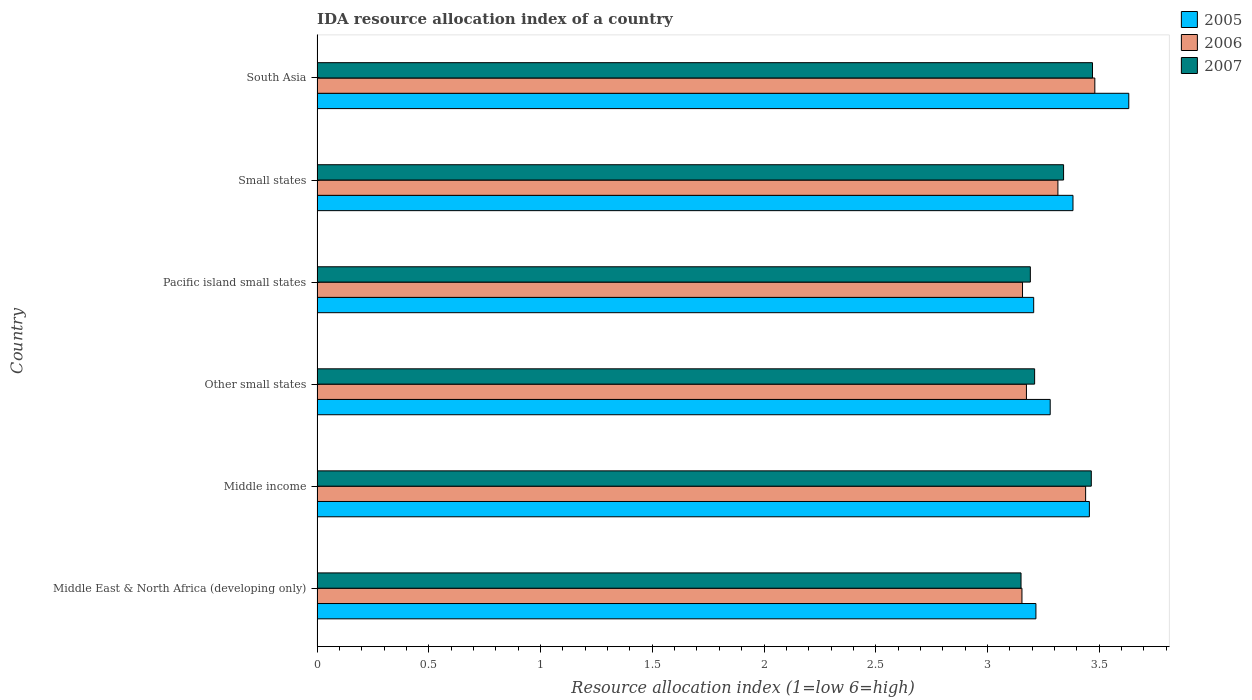How many different coloured bars are there?
Keep it short and to the point. 3. How many groups of bars are there?
Give a very brief answer. 6. Are the number of bars per tick equal to the number of legend labels?
Keep it short and to the point. Yes. Are the number of bars on each tick of the Y-axis equal?
Ensure brevity in your answer.  Yes. What is the label of the 3rd group of bars from the top?
Provide a short and direct response. Pacific island small states. In how many cases, is the number of bars for a given country not equal to the number of legend labels?
Your response must be concise. 0. What is the IDA resource allocation index in 2006 in Small states?
Make the answer very short. 3.31. Across all countries, what is the maximum IDA resource allocation index in 2006?
Your answer should be compact. 3.48. Across all countries, what is the minimum IDA resource allocation index in 2006?
Offer a very short reply. 3.15. In which country was the IDA resource allocation index in 2007 maximum?
Ensure brevity in your answer.  South Asia. In which country was the IDA resource allocation index in 2007 minimum?
Ensure brevity in your answer.  Middle East & North Africa (developing only). What is the total IDA resource allocation index in 2007 in the graph?
Offer a very short reply. 19.83. What is the difference between the IDA resource allocation index in 2005 in Other small states and that in South Asia?
Your response must be concise. -0.35. What is the difference between the IDA resource allocation index in 2006 in Other small states and the IDA resource allocation index in 2007 in Small states?
Your response must be concise. -0.17. What is the average IDA resource allocation index in 2006 per country?
Your answer should be compact. 3.29. What is the difference between the IDA resource allocation index in 2006 and IDA resource allocation index in 2005 in Small states?
Provide a short and direct response. -0.07. In how many countries, is the IDA resource allocation index in 2007 greater than 1 ?
Make the answer very short. 6. What is the ratio of the IDA resource allocation index in 2006 in Middle income to that in Other small states?
Give a very brief answer. 1.08. What is the difference between the highest and the second highest IDA resource allocation index in 2005?
Give a very brief answer. 0.18. What is the difference between the highest and the lowest IDA resource allocation index in 2005?
Keep it short and to the point. 0.43. In how many countries, is the IDA resource allocation index in 2005 greater than the average IDA resource allocation index in 2005 taken over all countries?
Your response must be concise. 3. What does the 1st bar from the top in Other small states represents?
Offer a terse response. 2007. What does the 1st bar from the bottom in Small states represents?
Your answer should be compact. 2005. Is it the case that in every country, the sum of the IDA resource allocation index in 2005 and IDA resource allocation index in 2007 is greater than the IDA resource allocation index in 2006?
Provide a short and direct response. Yes. How many bars are there?
Your answer should be compact. 18. Are the values on the major ticks of X-axis written in scientific E-notation?
Provide a succinct answer. No. Does the graph contain any zero values?
Make the answer very short. No. Does the graph contain grids?
Your answer should be very brief. No. Where does the legend appear in the graph?
Give a very brief answer. Top right. What is the title of the graph?
Give a very brief answer. IDA resource allocation index of a country. What is the label or title of the X-axis?
Offer a very short reply. Resource allocation index (1=low 6=high). What is the Resource allocation index (1=low 6=high) in 2005 in Middle East & North Africa (developing only)?
Offer a terse response. 3.22. What is the Resource allocation index (1=low 6=high) in 2006 in Middle East & North Africa (developing only)?
Offer a terse response. 3.15. What is the Resource allocation index (1=low 6=high) of 2007 in Middle East & North Africa (developing only)?
Make the answer very short. 3.15. What is the Resource allocation index (1=low 6=high) in 2005 in Middle income?
Offer a terse response. 3.46. What is the Resource allocation index (1=low 6=high) of 2006 in Middle income?
Provide a short and direct response. 3.44. What is the Resource allocation index (1=low 6=high) in 2007 in Middle income?
Provide a short and direct response. 3.46. What is the Resource allocation index (1=low 6=high) of 2005 in Other small states?
Provide a succinct answer. 3.28. What is the Resource allocation index (1=low 6=high) of 2006 in Other small states?
Keep it short and to the point. 3.17. What is the Resource allocation index (1=low 6=high) of 2007 in Other small states?
Make the answer very short. 3.21. What is the Resource allocation index (1=low 6=high) in 2005 in Pacific island small states?
Provide a short and direct response. 3.21. What is the Resource allocation index (1=low 6=high) in 2006 in Pacific island small states?
Your response must be concise. 3.16. What is the Resource allocation index (1=low 6=high) of 2007 in Pacific island small states?
Offer a terse response. 3.19. What is the Resource allocation index (1=low 6=high) of 2005 in Small states?
Offer a terse response. 3.38. What is the Resource allocation index (1=low 6=high) in 2006 in Small states?
Provide a succinct answer. 3.31. What is the Resource allocation index (1=low 6=high) in 2007 in Small states?
Provide a succinct answer. 3.34. What is the Resource allocation index (1=low 6=high) of 2005 in South Asia?
Your answer should be very brief. 3.63. What is the Resource allocation index (1=low 6=high) in 2006 in South Asia?
Offer a very short reply. 3.48. What is the Resource allocation index (1=low 6=high) in 2007 in South Asia?
Provide a short and direct response. 3.47. Across all countries, what is the maximum Resource allocation index (1=low 6=high) of 2005?
Offer a terse response. 3.63. Across all countries, what is the maximum Resource allocation index (1=low 6=high) in 2006?
Keep it short and to the point. 3.48. Across all countries, what is the maximum Resource allocation index (1=low 6=high) in 2007?
Give a very brief answer. 3.47. Across all countries, what is the minimum Resource allocation index (1=low 6=high) of 2005?
Ensure brevity in your answer.  3.21. Across all countries, what is the minimum Resource allocation index (1=low 6=high) of 2006?
Offer a very short reply. 3.15. Across all countries, what is the minimum Resource allocation index (1=low 6=high) of 2007?
Provide a short and direct response. 3.15. What is the total Resource allocation index (1=low 6=high) in 2005 in the graph?
Your response must be concise. 20.17. What is the total Resource allocation index (1=low 6=high) in 2006 in the graph?
Your response must be concise. 19.72. What is the total Resource allocation index (1=low 6=high) in 2007 in the graph?
Your answer should be compact. 19.83. What is the difference between the Resource allocation index (1=low 6=high) in 2005 in Middle East & North Africa (developing only) and that in Middle income?
Give a very brief answer. -0.24. What is the difference between the Resource allocation index (1=low 6=high) in 2006 in Middle East & North Africa (developing only) and that in Middle income?
Your answer should be compact. -0.28. What is the difference between the Resource allocation index (1=low 6=high) in 2007 in Middle East & North Africa (developing only) and that in Middle income?
Ensure brevity in your answer.  -0.31. What is the difference between the Resource allocation index (1=low 6=high) in 2005 in Middle East & North Africa (developing only) and that in Other small states?
Your response must be concise. -0.06. What is the difference between the Resource allocation index (1=low 6=high) in 2006 in Middle East & North Africa (developing only) and that in Other small states?
Your answer should be compact. -0.02. What is the difference between the Resource allocation index (1=low 6=high) in 2007 in Middle East & North Africa (developing only) and that in Other small states?
Provide a short and direct response. -0.06. What is the difference between the Resource allocation index (1=low 6=high) in 2006 in Middle East & North Africa (developing only) and that in Pacific island small states?
Provide a short and direct response. -0. What is the difference between the Resource allocation index (1=low 6=high) in 2007 in Middle East & North Africa (developing only) and that in Pacific island small states?
Ensure brevity in your answer.  -0.04. What is the difference between the Resource allocation index (1=low 6=high) of 2005 in Middle East & North Africa (developing only) and that in Small states?
Make the answer very short. -0.17. What is the difference between the Resource allocation index (1=low 6=high) in 2006 in Middle East & North Africa (developing only) and that in Small states?
Provide a short and direct response. -0.16. What is the difference between the Resource allocation index (1=low 6=high) of 2007 in Middle East & North Africa (developing only) and that in Small states?
Your response must be concise. -0.19. What is the difference between the Resource allocation index (1=low 6=high) in 2005 in Middle East & North Africa (developing only) and that in South Asia?
Give a very brief answer. -0.42. What is the difference between the Resource allocation index (1=low 6=high) of 2006 in Middle East & North Africa (developing only) and that in South Asia?
Your answer should be very brief. -0.33. What is the difference between the Resource allocation index (1=low 6=high) of 2007 in Middle East & North Africa (developing only) and that in South Asia?
Your answer should be compact. -0.32. What is the difference between the Resource allocation index (1=low 6=high) of 2005 in Middle income and that in Other small states?
Your response must be concise. 0.18. What is the difference between the Resource allocation index (1=low 6=high) of 2006 in Middle income and that in Other small states?
Make the answer very short. 0.26. What is the difference between the Resource allocation index (1=low 6=high) in 2007 in Middle income and that in Other small states?
Your response must be concise. 0.25. What is the difference between the Resource allocation index (1=low 6=high) of 2005 in Middle income and that in Pacific island small states?
Provide a short and direct response. 0.25. What is the difference between the Resource allocation index (1=low 6=high) of 2006 in Middle income and that in Pacific island small states?
Provide a short and direct response. 0.28. What is the difference between the Resource allocation index (1=low 6=high) in 2007 in Middle income and that in Pacific island small states?
Keep it short and to the point. 0.27. What is the difference between the Resource allocation index (1=low 6=high) of 2005 in Middle income and that in Small states?
Ensure brevity in your answer.  0.07. What is the difference between the Resource allocation index (1=low 6=high) of 2006 in Middle income and that in Small states?
Offer a very short reply. 0.12. What is the difference between the Resource allocation index (1=low 6=high) in 2007 in Middle income and that in Small states?
Your response must be concise. 0.12. What is the difference between the Resource allocation index (1=low 6=high) in 2005 in Middle income and that in South Asia?
Keep it short and to the point. -0.18. What is the difference between the Resource allocation index (1=low 6=high) in 2006 in Middle income and that in South Asia?
Offer a very short reply. -0.04. What is the difference between the Resource allocation index (1=low 6=high) in 2007 in Middle income and that in South Asia?
Provide a short and direct response. -0.01. What is the difference between the Resource allocation index (1=low 6=high) of 2005 in Other small states and that in Pacific island small states?
Offer a very short reply. 0.07. What is the difference between the Resource allocation index (1=low 6=high) in 2006 in Other small states and that in Pacific island small states?
Give a very brief answer. 0.02. What is the difference between the Resource allocation index (1=low 6=high) in 2007 in Other small states and that in Pacific island small states?
Give a very brief answer. 0.02. What is the difference between the Resource allocation index (1=low 6=high) of 2005 in Other small states and that in Small states?
Make the answer very short. -0.1. What is the difference between the Resource allocation index (1=low 6=high) in 2006 in Other small states and that in Small states?
Provide a short and direct response. -0.14. What is the difference between the Resource allocation index (1=low 6=high) in 2007 in Other small states and that in Small states?
Make the answer very short. -0.13. What is the difference between the Resource allocation index (1=low 6=high) of 2005 in Other small states and that in South Asia?
Your answer should be compact. -0.35. What is the difference between the Resource allocation index (1=low 6=high) of 2006 in Other small states and that in South Asia?
Ensure brevity in your answer.  -0.31. What is the difference between the Resource allocation index (1=low 6=high) in 2007 in Other small states and that in South Asia?
Your response must be concise. -0.26. What is the difference between the Resource allocation index (1=low 6=high) of 2005 in Pacific island small states and that in Small states?
Provide a succinct answer. -0.18. What is the difference between the Resource allocation index (1=low 6=high) in 2006 in Pacific island small states and that in Small states?
Make the answer very short. -0.16. What is the difference between the Resource allocation index (1=low 6=high) of 2007 in Pacific island small states and that in Small states?
Give a very brief answer. -0.15. What is the difference between the Resource allocation index (1=low 6=high) of 2005 in Pacific island small states and that in South Asia?
Offer a very short reply. -0.43. What is the difference between the Resource allocation index (1=low 6=high) of 2006 in Pacific island small states and that in South Asia?
Ensure brevity in your answer.  -0.32. What is the difference between the Resource allocation index (1=low 6=high) in 2007 in Pacific island small states and that in South Asia?
Your answer should be very brief. -0.28. What is the difference between the Resource allocation index (1=low 6=high) of 2005 in Small states and that in South Asia?
Provide a succinct answer. -0.25. What is the difference between the Resource allocation index (1=low 6=high) in 2006 in Small states and that in South Asia?
Give a very brief answer. -0.17. What is the difference between the Resource allocation index (1=low 6=high) in 2007 in Small states and that in South Asia?
Provide a short and direct response. -0.13. What is the difference between the Resource allocation index (1=low 6=high) in 2005 in Middle East & North Africa (developing only) and the Resource allocation index (1=low 6=high) in 2006 in Middle income?
Make the answer very short. -0.22. What is the difference between the Resource allocation index (1=low 6=high) of 2005 in Middle East & North Africa (developing only) and the Resource allocation index (1=low 6=high) of 2007 in Middle income?
Provide a succinct answer. -0.25. What is the difference between the Resource allocation index (1=low 6=high) of 2006 in Middle East & North Africa (developing only) and the Resource allocation index (1=low 6=high) of 2007 in Middle income?
Provide a succinct answer. -0.31. What is the difference between the Resource allocation index (1=low 6=high) in 2005 in Middle East & North Africa (developing only) and the Resource allocation index (1=low 6=high) in 2006 in Other small states?
Your answer should be compact. 0.04. What is the difference between the Resource allocation index (1=low 6=high) in 2005 in Middle East & North Africa (developing only) and the Resource allocation index (1=low 6=high) in 2007 in Other small states?
Provide a short and direct response. 0.01. What is the difference between the Resource allocation index (1=low 6=high) of 2006 in Middle East & North Africa (developing only) and the Resource allocation index (1=low 6=high) of 2007 in Other small states?
Make the answer very short. -0.06. What is the difference between the Resource allocation index (1=low 6=high) of 2005 in Middle East & North Africa (developing only) and the Resource allocation index (1=low 6=high) of 2007 in Pacific island small states?
Provide a short and direct response. 0.03. What is the difference between the Resource allocation index (1=low 6=high) of 2006 in Middle East & North Africa (developing only) and the Resource allocation index (1=low 6=high) of 2007 in Pacific island small states?
Ensure brevity in your answer.  -0.04. What is the difference between the Resource allocation index (1=low 6=high) in 2005 in Middle East & North Africa (developing only) and the Resource allocation index (1=low 6=high) in 2006 in Small states?
Your response must be concise. -0.1. What is the difference between the Resource allocation index (1=low 6=high) in 2005 in Middle East & North Africa (developing only) and the Resource allocation index (1=low 6=high) in 2007 in Small states?
Keep it short and to the point. -0.12. What is the difference between the Resource allocation index (1=low 6=high) in 2006 in Middle East & North Africa (developing only) and the Resource allocation index (1=low 6=high) in 2007 in Small states?
Offer a terse response. -0.19. What is the difference between the Resource allocation index (1=low 6=high) in 2005 in Middle East & North Africa (developing only) and the Resource allocation index (1=low 6=high) in 2006 in South Asia?
Your answer should be compact. -0.26. What is the difference between the Resource allocation index (1=low 6=high) of 2005 in Middle East & North Africa (developing only) and the Resource allocation index (1=low 6=high) of 2007 in South Asia?
Give a very brief answer. -0.25. What is the difference between the Resource allocation index (1=low 6=high) of 2006 in Middle East & North Africa (developing only) and the Resource allocation index (1=low 6=high) of 2007 in South Asia?
Offer a terse response. -0.32. What is the difference between the Resource allocation index (1=low 6=high) of 2005 in Middle income and the Resource allocation index (1=low 6=high) of 2006 in Other small states?
Ensure brevity in your answer.  0.28. What is the difference between the Resource allocation index (1=low 6=high) of 2005 in Middle income and the Resource allocation index (1=low 6=high) of 2007 in Other small states?
Make the answer very short. 0.24. What is the difference between the Resource allocation index (1=low 6=high) in 2006 in Middle income and the Resource allocation index (1=low 6=high) in 2007 in Other small states?
Give a very brief answer. 0.23. What is the difference between the Resource allocation index (1=low 6=high) of 2005 in Middle income and the Resource allocation index (1=low 6=high) of 2006 in Pacific island small states?
Your answer should be compact. 0.3. What is the difference between the Resource allocation index (1=low 6=high) of 2005 in Middle income and the Resource allocation index (1=low 6=high) of 2007 in Pacific island small states?
Provide a succinct answer. 0.26. What is the difference between the Resource allocation index (1=low 6=high) of 2006 in Middle income and the Resource allocation index (1=low 6=high) of 2007 in Pacific island small states?
Make the answer very short. 0.25. What is the difference between the Resource allocation index (1=low 6=high) in 2005 in Middle income and the Resource allocation index (1=low 6=high) in 2006 in Small states?
Your answer should be very brief. 0.14. What is the difference between the Resource allocation index (1=low 6=high) in 2005 in Middle income and the Resource allocation index (1=low 6=high) in 2007 in Small states?
Offer a terse response. 0.12. What is the difference between the Resource allocation index (1=low 6=high) of 2006 in Middle income and the Resource allocation index (1=low 6=high) of 2007 in Small states?
Make the answer very short. 0.1. What is the difference between the Resource allocation index (1=low 6=high) in 2005 in Middle income and the Resource allocation index (1=low 6=high) in 2006 in South Asia?
Provide a short and direct response. -0.02. What is the difference between the Resource allocation index (1=low 6=high) of 2005 in Middle income and the Resource allocation index (1=low 6=high) of 2007 in South Asia?
Offer a very short reply. -0.01. What is the difference between the Resource allocation index (1=low 6=high) in 2006 in Middle income and the Resource allocation index (1=low 6=high) in 2007 in South Asia?
Offer a very short reply. -0.03. What is the difference between the Resource allocation index (1=low 6=high) in 2005 in Other small states and the Resource allocation index (1=low 6=high) in 2006 in Pacific island small states?
Offer a terse response. 0.12. What is the difference between the Resource allocation index (1=low 6=high) in 2005 in Other small states and the Resource allocation index (1=low 6=high) in 2007 in Pacific island small states?
Ensure brevity in your answer.  0.09. What is the difference between the Resource allocation index (1=low 6=high) of 2006 in Other small states and the Resource allocation index (1=low 6=high) of 2007 in Pacific island small states?
Ensure brevity in your answer.  -0.02. What is the difference between the Resource allocation index (1=low 6=high) of 2005 in Other small states and the Resource allocation index (1=low 6=high) of 2006 in Small states?
Ensure brevity in your answer.  -0.03. What is the difference between the Resource allocation index (1=low 6=high) of 2005 in Other small states and the Resource allocation index (1=low 6=high) of 2007 in Small states?
Provide a short and direct response. -0.06. What is the difference between the Resource allocation index (1=low 6=high) of 2006 in Other small states and the Resource allocation index (1=low 6=high) of 2007 in Small states?
Your answer should be compact. -0.17. What is the difference between the Resource allocation index (1=low 6=high) in 2005 in Other small states and the Resource allocation index (1=low 6=high) in 2006 in South Asia?
Ensure brevity in your answer.  -0.2. What is the difference between the Resource allocation index (1=low 6=high) of 2005 in Other small states and the Resource allocation index (1=low 6=high) of 2007 in South Asia?
Your answer should be very brief. -0.19. What is the difference between the Resource allocation index (1=low 6=high) of 2006 in Other small states and the Resource allocation index (1=low 6=high) of 2007 in South Asia?
Ensure brevity in your answer.  -0.3. What is the difference between the Resource allocation index (1=low 6=high) in 2005 in Pacific island small states and the Resource allocation index (1=low 6=high) in 2006 in Small states?
Your answer should be compact. -0.11. What is the difference between the Resource allocation index (1=low 6=high) of 2005 in Pacific island small states and the Resource allocation index (1=low 6=high) of 2007 in Small states?
Make the answer very short. -0.13. What is the difference between the Resource allocation index (1=low 6=high) of 2006 in Pacific island small states and the Resource allocation index (1=low 6=high) of 2007 in Small states?
Your answer should be very brief. -0.18. What is the difference between the Resource allocation index (1=low 6=high) in 2005 in Pacific island small states and the Resource allocation index (1=low 6=high) in 2006 in South Asia?
Give a very brief answer. -0.27. What is the difference between the Resource allocation index (1=low 6=high) of 2005 in Pacific island small states and the Resource allocation index (1=low 6=high) of 2007 in South Asia?
Your response must be concise. -0.26. What is the difference between the Resource allocation index (1=low 6=high) in 2006 in Pacific island small states and the Resource allocation index (1=low 6=high) in 2007 in South Asia?
Your response must be concise. -0.31. What is the difference between the Resource allocation index (1=low 6=high) of 2005 in Small states and the Resource allocation index (1=low 6=high) of 2006 in South Asia?
Ensure brevity in your answer.  -0.1. What is the difference between the Resource allocation index (1=low 6=high) of 2005 in Small states and the Resource allocation index (1=low 6=high) of 2007 in South Asia?
Provide a succinct answer. -0.09. What is the difference between the Resource allocation index (1=low 6=high) of 2006 in Small states and the Resource allocation index (1=low 6=high) of 2007 in South Asia?
Provide a short and direct response. -0.15. What is the average Resource allocation index (1=low 6=high) in 2005 per country?
Offer a terse response. 3.36. What is the average Resource allocation index (1=low 6=high) in 2006 per country?
Your response must be concise. 3.29. What is the average Resource allocation index (1=low 6=high) in 2007 per country?
Provide a short and direct response. 3.3. What is the difference between the Resource allocation index (1=low 6=high) in 2005 and Resource allocation index (1=low 6=high) in 2006 in Middle East & North Africa (developing only)?
Offer a terse response. 0.06. What is the difference between the Resource allocation index (1=low 6=high) of 2005 and Resource allocation index (1=low 6=high) of 2007 in Middle East & North Africa (developing only)?
Offer a very short reply. 0.07. What is the difference between the Resource allocation index (1=low 6=high) of 2006 and Resource allocation index (1=low 6=high) of 2007 in Middle East & North Africa (developing only)?
Your answer should be very brief. 0. What is the difference between the Resource allocation index (1=low 6=high) of 2005 and Resource allocation index (1=low 6=high) of 2006 in Middle income?
Your response must be concise. 0.02. What is the difference between the Resource allocation index (1=low 6=high) in 2005 and Resource allocation index (1=low 6=high) in 2007 in Middle income?
Offer a very short reply. -0.01. What is the difference between the Resource allocation index (1=low 6=high) in 2006 and Resource allocation index (1=low 6=high) in 2007 in Middle income?
Your answer should be very brief. -0.03. What is the difference between the Resource allocation index (1=low 6=high) of 2005 and Resource allocation index (1=low 6=high) of 2006 in Other small states?
Your answer should be compact. 0.11. What is the difference between the Resource allocation index (1=low 6=high) of 2005 and Resource allocation index (1=low 6=high) of 2007 in Other small states?
Your answer should be very brief. 0.07. What is the difference between the Resource allocation index (1=low 6=high) of 2006 and Resource allocation index (1=low 6=high) of 2007 in Other small states?
Make the answer very short. -0.04. What is the difference between the Resource allocation index (1=low 6=high) of 2005 and Resource allocation index (1=low 6=high) of 2007 in Pacific island small states?
Offer a terse response. 0.01. What is the difference between the Resource allocation index (1=low 6=high) in 2006 and Resource allocation index (1=low 6=high) in 2007 in Pacific island small states?
Your response must be concise. -0.04. What is the difference between the Resource allocation index (1=low 6=high) of 2005 and Resource allocation index (1=low 6=high) of 2006 in Small states?
Your response must be concise. 0.07. What is the difference between the Resource allocation index (1=low 6=high) in 2005 and Resource allocation index (1=low 6=high) in 2007 in Small states?
Give a very brief answer. 0.04. What is the difference between the Resource allocation index (1=low 6=high) in 2006 and Resource allocation index (1=low 6=high) in 2007 in Small states?
Offer a terse response. -0.03. What is the difference between the Resource allocation index (1=low 6=high) in 2005 and Resource allocation index (1=low 6=high) in 2006 in South Asia?
Your answer should be compact. 0.15. What is the difference between the Resource allocation index (1=low 6=high) of 2005 and Resource allocation index (1=low 6=high) of 2007 in South Asia?
Your response must be concise. 0.16. What is the difference between the Resource allocation index (1=low 6=high) in 2006 and Resource allocation index (1=low 6=high) in 2007 in South Asia?
Provide a succinct answer. 0.01. What is the ratio of the Resource allocation index (1=low 6=high) of 2005 in Middle East & North Africa (developing only) to that in Middle income?
Keep it short and to the point. 0.93. What is the ratio of the Resource allocation index (1=low 6=high) in 2006 in Middle East & North Africa (developing only) to that in Middle income?
Keep it short and to the point. 0.92. What is the ratio of the Resource allocation index (1=low 6=high) of 2007 in Middle East & North Africa (developing only) to that in Middle income?
Provide a short and direct response. 0.91. What is the ratio of the Resource allocation index (1=low 6=high) of 2005 in Middle East & North Africa (developing only) to that in Other small states?
Provide a succinct answer. 0.98. What is the ratio of the Resource allocation index (1=low 6=high) in 2006 in Middle East & North Africa (developing only) to that in Other small states?
Your response must be concise. 0.99. What is the ratio of the Resource allocation index (1=low 6=high) of 2007 in Middle East & North Africa (developing only) to that in Other small states?
Provide a short and direct response. 0.98. What is the ratio of the Resource allocation index (1=low 6=high) in 2005 in Middle East & North Africa (developing only) to that in Pacific island small states?
Your response must be concise. 1. What is the ratio of the Resource allocation index (1=low 6=high) of 2007 in Middle East & North Africa (developing only) to that in Pacific island small states?
Your answer should be very brief. 0.99. What is the ratio of the Resource allocation index (1=low 6=high) in 2005 in Middle East & North Africa (developing only) to that in Small states?
Make the answer very short. 0.95. What is the ratio of the Resource allocation index (1=low 6=high) of 2006 in Middle East & North Africa (developing only) to that in Small states?
Your response must be concise. 0.95. What is the ratio of the Resource allocation index (1=low 6=high) of 2007 in Middle East & North Africa (developing only) to that in Small states?
Offer a terse response. 0.94. What is the ratio of the Resource allocation index (1=low 6=high) in 2005 in Middle East & North Africa (developing only) to that in South Asia?
Give a very brief answer. 0.89. What is the ratio of the Resource allocation index (1=low 6=high) of 2006 in Middle East & North Africa (developing only) to that in South Asia?
Offer a very short reply. 0.91. What is the ratio of the Resource allocation index (1=low 6=high) in 2007 in Middle East & North Africa (developing only) to that in South Asia?
Your response must be concise. 0.91. What is the ratio of the Resource allocation index (1=low 6=high) of 2005 in Middle income to that in Other small states?
Ensure brevity in your answer.  1.05. What is the ratio of the Resource allocation index (1=low 6=high) in 2006 in Middle income to that in Other small states?
Provide a short and direct response. 1.08. What is the ratio of the Resource allocation index (1=low 6=high) in 2007 in Middle income to that in Other small states?
Offer a terse response. 1.08. What is the ratio of the Resource allocation index (1=low 6=high) of 2005 in Middle income to that in Pacific island small states?
Give a very brief answer. 1.08. What is the ratio of the Resource allocation index (1=low 6=high) in 2006 in Middle income to that in Pacific island small states?
Provide a short and direct response. 1.09. What is the ratio of the Resource allocation index (1=low 6=high) of 2007 in Middle income to that in Pacific island small states?
Offer a terse response. 1.09. What is the ratio of the Resource allocation index (1=low 6=high) of 2005 in Middle income to that in Small states?
Offer a very short reply. 1.02. What is the ratio of the Resource allocation index (1=low 6=high) of 2006 in Middle income to that in Small states?
Offer a terse response. 1.04. What is the ratio of the Resource allocation index (1=low 6=high) of 2007 in Middle income to that in Small states?
Provide a succinct answer. 1.04. What is the ratio of the Resource allocation index (1=low 6=high) in 2005 in Middle income to that in South Asia?
Offer a terse response. 0.95. What is the ratio of the Resource allocation index (1=low 6=high) in 2006 in Middle income to that in South Asia?
Your answer should be compact. 0.99. What is the ratio of the Resource allocation index (1=low 6=high) of 2007 in Other small states to that in Pacific island small states?
Offer a very short reply. 1.01. What is the ratio of the Resource allocation index (1=low 6=high) in 2005 in Other small states to that in Small states?
Provide a short and direct response. 0.97. What is the ratio of the Resource allocation index (1=low 6=high) of 2006 in Other small states to that in Small states?
Provide a succinct answer. 0.96. What is the ratio of the Resource allocation index (1=low 6=high) in 2007 in Other small states to that in Small states?
Ensure brevity in your answer.  0.96. What is the ratio of the Resource allocation index (1=low 6=high) of 2005 in Other small states to that in South Asia?
Offer a very short reply. 0.9. What is the ratio of the Resource allocation index (1=low 6=high) of 2006 in Other small states to that in South Asia?
Provide a short and direct response. 0.91. What is the ratio of the Resource allocation index (1=low 6=high) of 2007 in Other small states to that in South Asia?
Provide a succinct answer. 0.93. What is the ratio of the Resource allocation index (1=low 6=high) in 2005 in Pacific island small states to that in Small states?
Provide a short and direct response. 0.95. What is the ratio of the Resource allocation index (1=low 6=high) of 2006 in Pacific island small states to that in Small states?
Your response must be concise. 0.95. What is the ratio of the Resource allocation index (1=low 6=high) of 2007 in Pacific island small states to that in Small states?
Give a very brief answer. 0.96. What is the ratio of the Resource allocation index (1=low 6=high) in 2005 in Pacific island small states to that in South Asia?
Give a very brief answer. 0.88. What is the ratio of the Resource allocation index (1=low 6=high) in 2006 in Pacific island small states to that in South Asia?
Provide a succinct answer. 0.91. What is the ratio of the Resource allocation index (1=low 6=high) of 2007 in Pacific island small states to that in South Asia?
Your answer should be compact. 0.92. What is the ratio of the Resource allocation index (1=low 6=high) of 2005 in Small states to that in South Asia?
Give a very brief answer. 0.93. What is the ratio of the Resource allocation index (1=low 6=high) of 2006 in Small states to that in South Asia?
Your response must be concise. 0.95. What is the ratio of the Resource allocation index (1=low 6=high) of 2007 in Small states to that in South Asia?
Keep it short and to the point. 0.96. What is the difference between the highest and the second highest Resource allocation index (1=low 6=high) in 2005?
Offer a very short reply. 0.18. What is the difference between the highest and the second highest Resource allocation index (1=low 6=high) in 2006?
Make the answer very short. 0.04. What is the difference between the highest and the second highest Resource allocation index (1=low 6=high) of 2007?
Your response must be concise. 0.01. What is the difference between the highest and the lowest Resource allocation index (1=low 6=high) in 2005?
Ensure brevity in your answer.  0.43. What is the difference between the highest and the lowest Resource allocation index (1=low 6=high) of 2006?
Your answer should be compact. 0.33. What is the difference between the highest and the lowest Resource allocation index (1=low 6=high) in 2007?
Keep it short and to the point. 0.32. 